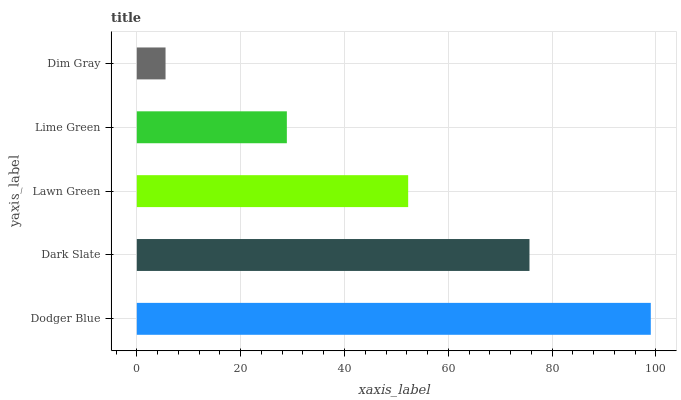Is Dim Gray the minimum?
Answer yes or no. Yes. Is Dodger Blue the maximum?
Answer yes or no. Yes. Is Dark Slate the minimum?
Answer yes or no. No. Is Dark Slate the maximum?
Answer yes or no. No. Is Dodger Blue greater than Dark Slate?
Answer yes or no. Yes. Is Dark Slate less than Dodger Blue?
Answer yes or no. Yes. Is Dark Slate greater than Dodger Blue?
Answer yes or no. No. Is Dodger Blue less than Dark Slate?
Answer yes or no. No. Is Lawn Green the high median?
Answer yes or no. Yes. Is Lawn Green the low median?
Answer yes or no. Yes. Is Dim Gray the high median?
Answer yes or no. No. Is Dodger Blue the low median?
Answer yes or no. No. 